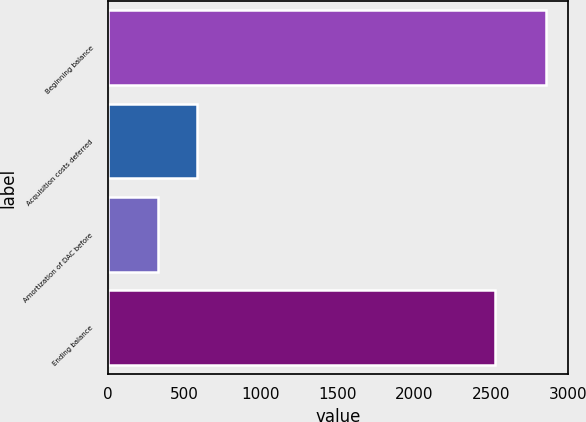<chart> <loc_0><loc_0><loc_500><loc_500><bar_chart><fcel>Beginning balance<fcel>Acquisition costs deferred<fcel>Amortization of DAC before<fcel>Ending balance<nl><fcel>2859<fcel>583.8<fcel>331<fcel>2523<nl></chart> 